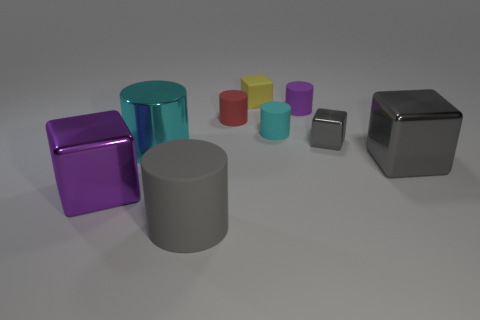Is there a yellow ball of the same size as the purple cylinder?
Offer a terse response. No. What is the material of the gray cube in front of the tiny block that is in front of the block behind the tiny red cylinder?
Provide a succinct answer. Metal. There is a big cyan metal thing left of the gray cylinder; how many small red rubber cylinders are in front of it?
Give a very brief answer. 0. There is a purple object that is on the left side of the metal cylinder; is it the same size as the big gray cube?
Provide a succinct answer. Yes. What number of large purple objects are the same shape as the large cyan metallic thing?
Provide a short and direct response. 0. There is a purple rubber thing; what shape is it?
Your response must be concise. Cylinder. Is the number of big gray cylinders that are behind the purple rubber thing the same as the number of purple blocks?
Your answer should be compact. No. Is there anything else that has the same material as the tiny red cylinder?
Ensure brevity in your answer.  Yes. Do the small cyan cylinder on the right side of the small red matte cylinder and the big purple thing have the same material?
Your answer should be compact. No. Are there fewer large matte cylinders that are on the right side of the small red rubber cylinder than large cubes?
Keep it short and to the point. Yes. 